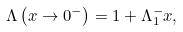<formula> <loc_0><loc_0><loc_500><loc_500>\Lambda \left ( x \rightarrow 0 ^ { - } \right ) = 1 + \Lambda _ { 1 } ^ { - } x ,</formula> 